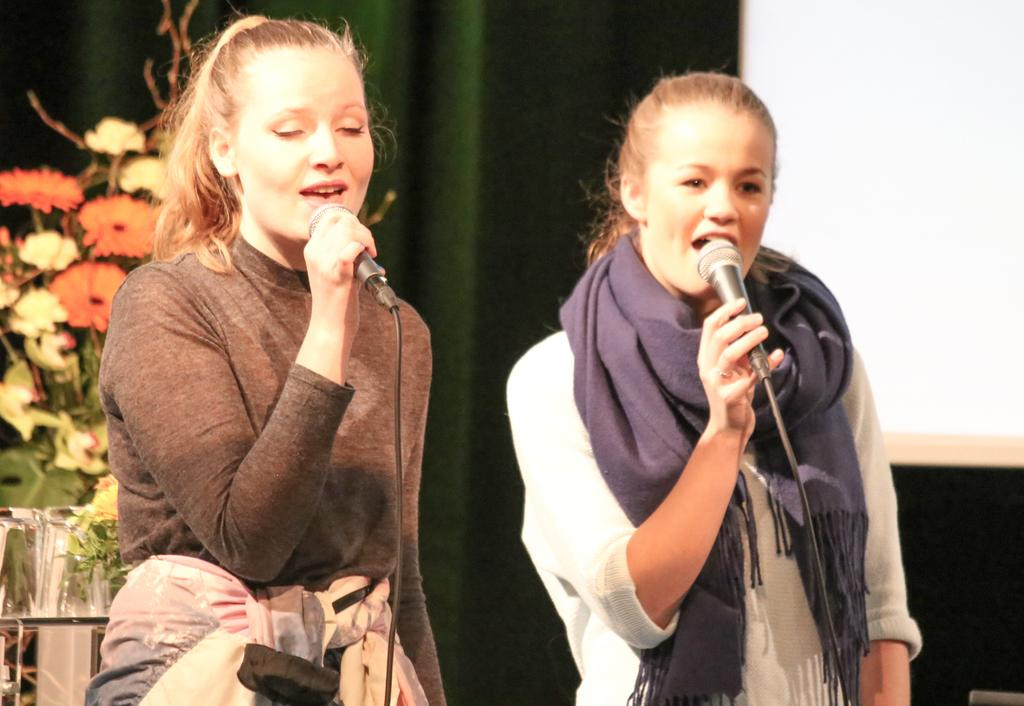How many women are in the image? There are two women in the image. What are the women doing in the image? The women are singing in the image. What tools are the women using while singing? The women are using microphones in the image. What can be seen in the background behind the women? There are flowers visible behind the women. What type of fabric is present in the image? There is a curtain in the image. What type of cup is being used by the women while singing in the image? There is no cup visible in the image; the women are using microphones while singing. 